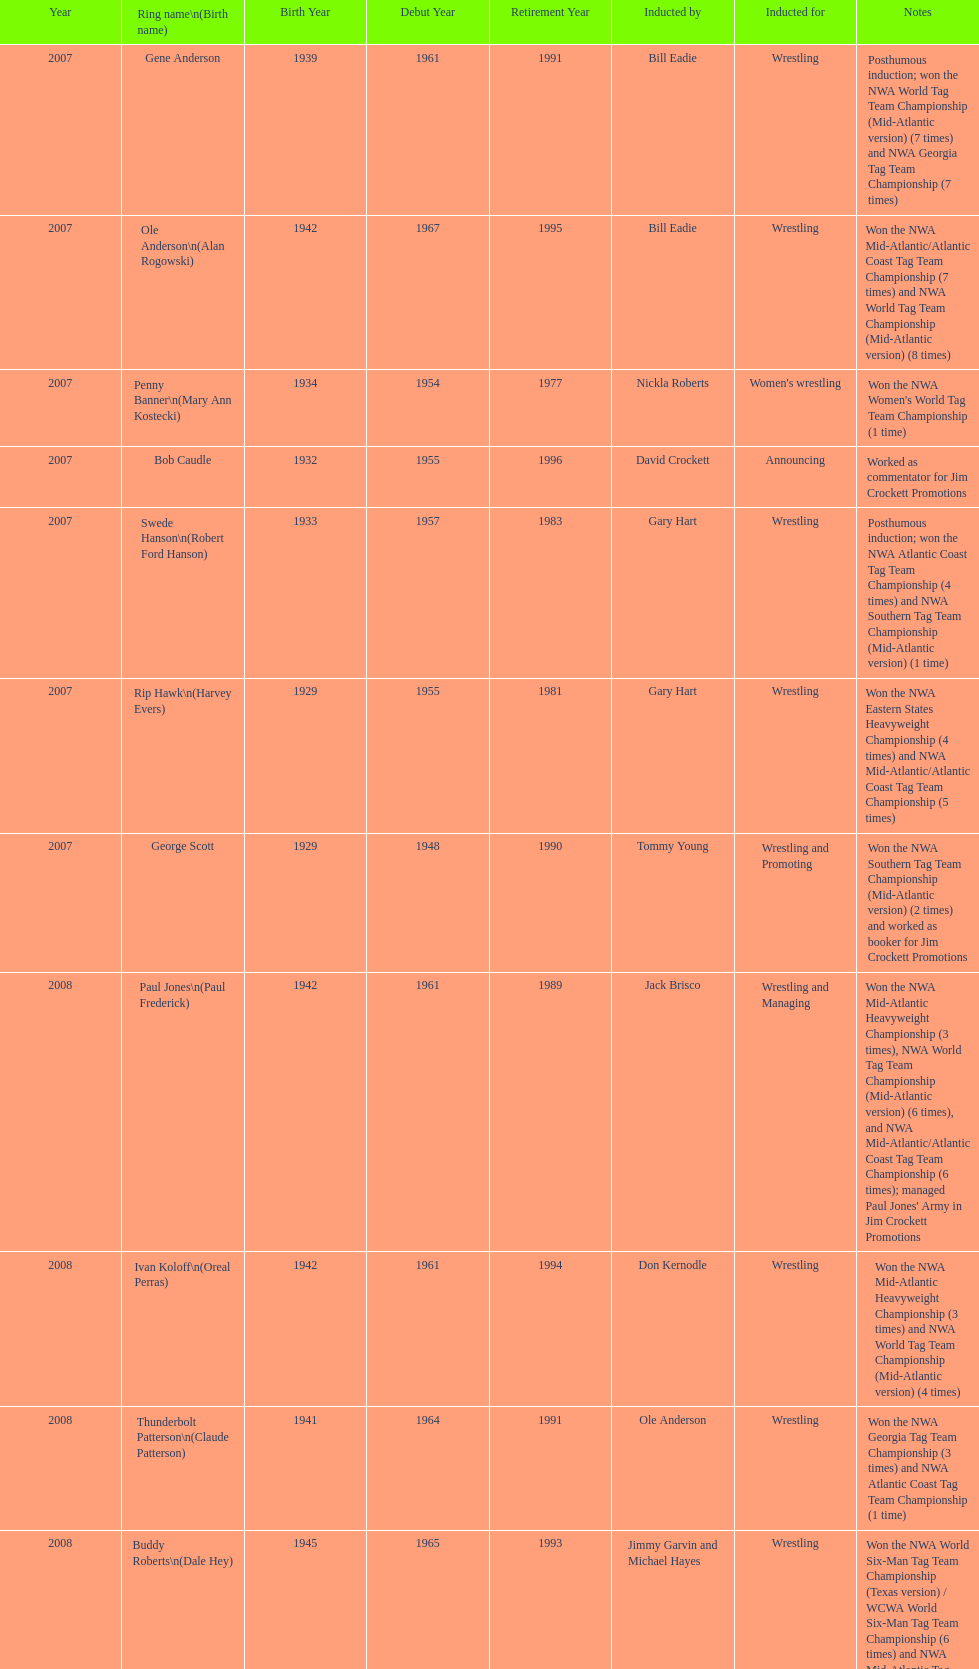Who won the most nwa southern tag team championships (mid-america version)? Jackie Fargo. 